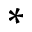<formula> <loc_0><loc_0><loc_500><loc_500>*</formula> 